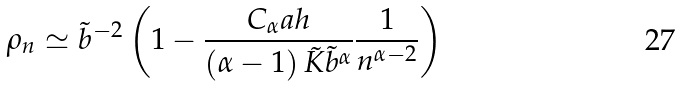Convert formula to latex. <formula><loc_0><loc_0><loc_500><loc_500>\rho _ { n } \simeq \tilde { b } ^ { - 2 } \left ( 1 - \frac { C _ { \alpha } a h } { \left ( \alpha - 1 \right ) \tilde { K } \tilde { b } ^ { \alpha } } \frac { 1 } { n ^ { \alpha - 2 } } \right )</formula> 